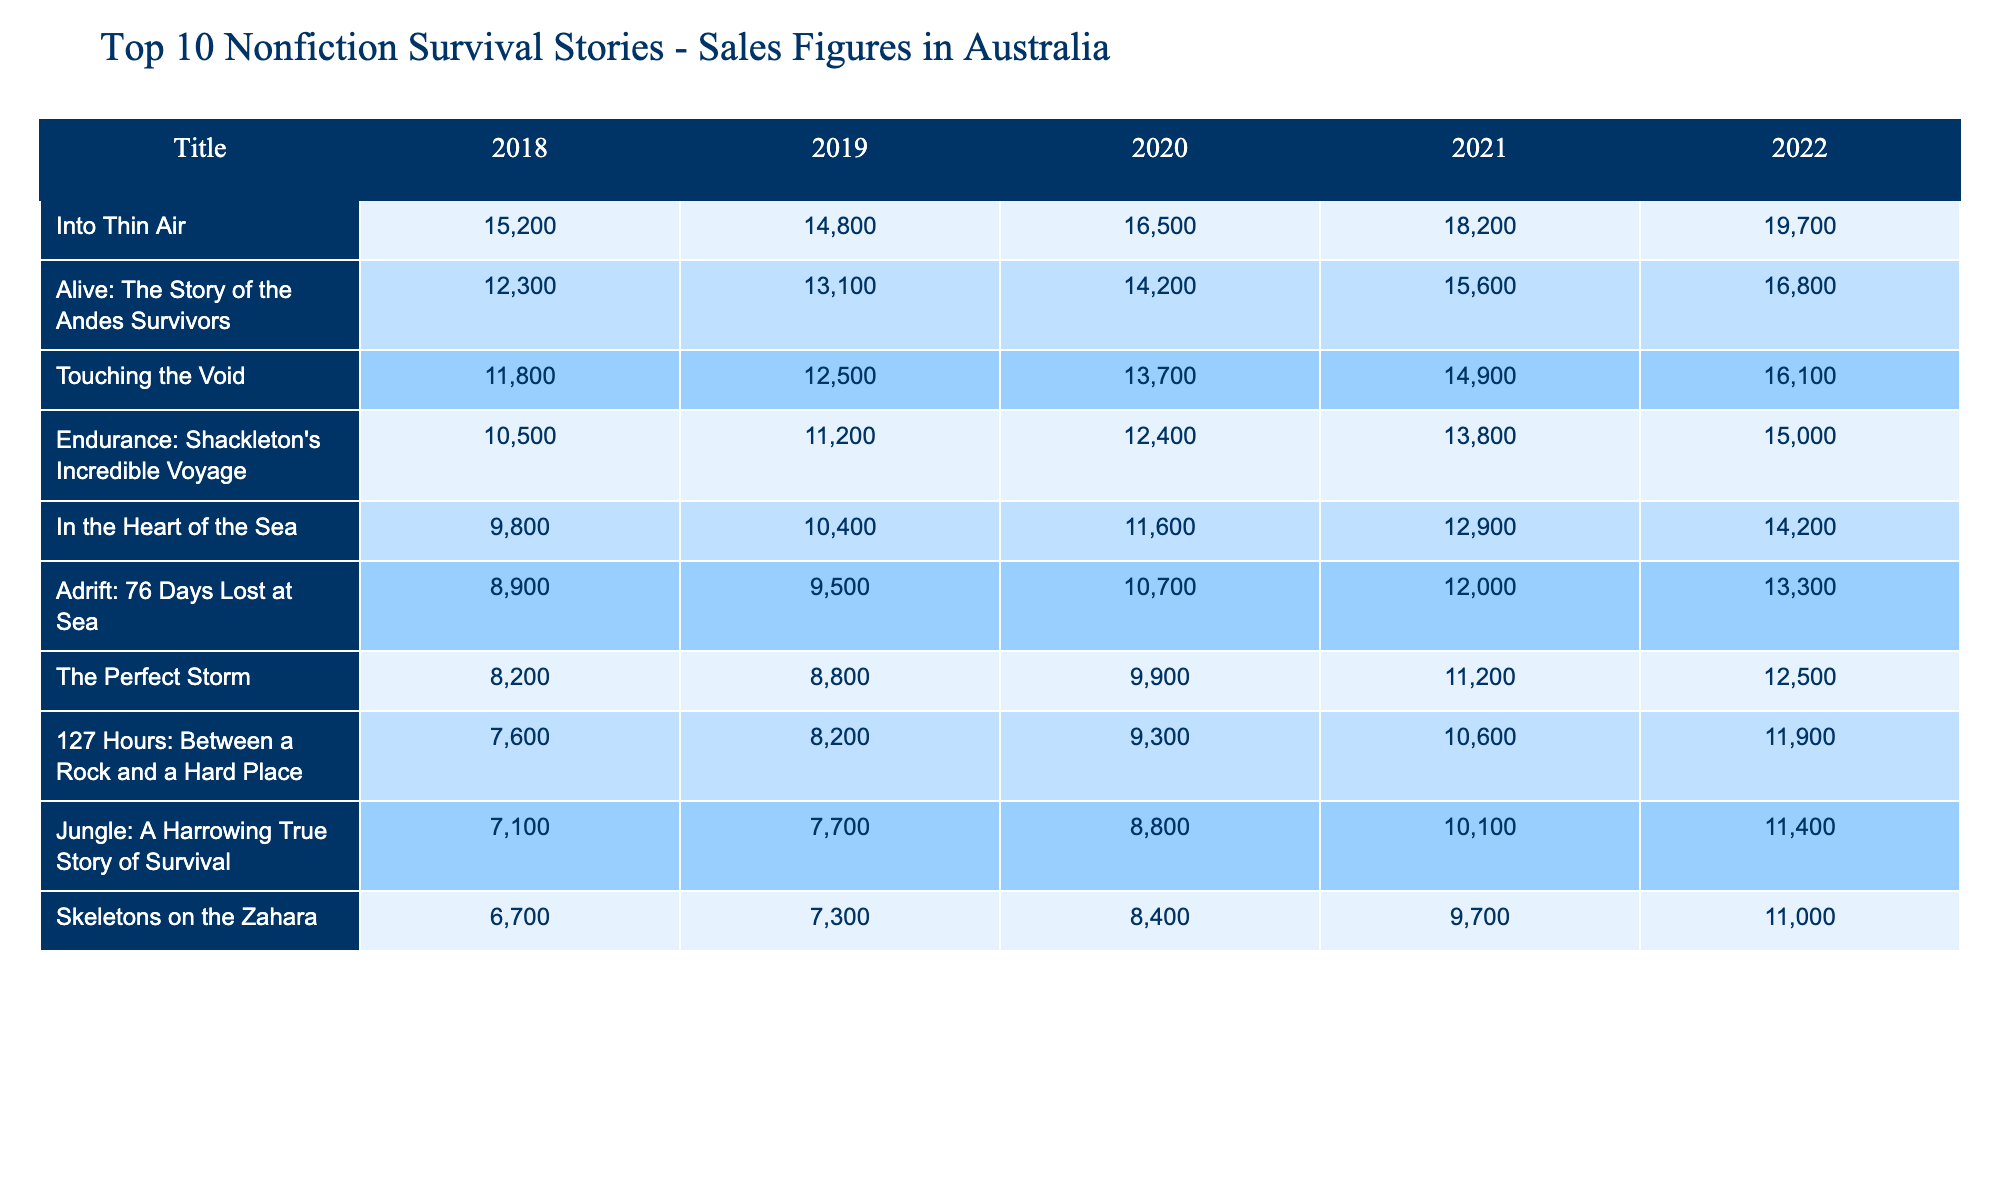What is the sales figure for "Touching the Void" in 2021? The table shows that "Touching the Void" sold 14,900 copies in 2021, as listed under the respective year column.
Answer: 14,900 Which book had the highest sales in 2022? By examining the last column for 2022, "Into Thin Air" is recorded with 19,700 sales, making it the highest selling book that year.
Answer: "Into Thin Air" What is the average sales figure for "Adrift: 76 Days Lost at Sea" over the five years? The sales figures for "Adrift: 76 Days Lost at Sea" over the five years are: 8,900, 9,500, 10,700, 12,000, and 13,300. The total is 8,900 + 9,500 + 10,700 + 12,000 + 13,300 = 54,400. To find the average, divide by 5: 54,400 / 5 = 10,880.
Answer: 10,880 Did the sales of "Endurance: Shackleton's Incredible Voyage" increase every year from 2018 to 2022? By checking each year's sales data for "Endurance: Shackleton's Incredible Voyage," we find it increased from 10,500 in 2018 to 15,000 in 2022. Since each value is greater than the previous one, the sales did increase every year.
Answer: Yes What book had the smallest sales in 2019, and what was the sales figure? In 2019, checking the sales figures reveals that "127 Hours: Between a Rock and a Hard Place" had the smallest sales figure of 8,200 compared to the others listed that year.
Answer: "127 Hours: Between a Rock and a Hard Place", 8,200 What was the difference in sales for "Alive: The Story of the Andes Survivors" between 2018 and 2022? The sales in 2018 were 12,300 and in 2022 they were 16,800. To find the difference, calculate 16,800 - 12,300 = 4,500.
Answer: 4,500 How many copies did the book "Skeletons on the Zahara" sell in total over the five years? The sales for "Skeletons on the Zahara" over the five years are: 6,700, 7,300, 8,400, 9,700, and 11,000. Summing these gives 6,700 + 7,300 + 8,400 + 9,700 + 11,000 = 43,100.
Answer: 43,100 Which book had the largest increase in sales from 2020 to 2021? Analyzing the increases from 2020 to 2021 for all books, "Into Thin Air" increased from 16,500 to 18,200 resulting in an increase of 1,700, which is the largest among them.
Answer: "Into Thin Air", 1,700 What was the total sales figure for the top three selling books in 2022? To find the total sales for the top three books in 2022, we sum the sales of "Into Thin Air" (19,700), "Alive: The Story of the Andes Survivors" (16,800), and "Touching the Void" (16,100). Thus, 19,700 + 16,800 + 16,100 = 52,600.
Answer: 52,600 Did "Jungle: A Harrowing True Story of Survival" ever surpass 10,000 sales in any year? Reviewing the sales figures, "Jungle" was below 10,000 in 2018 (7,100), 2019 (7,700), and 2020 (8,800) but reached 10,100 in 2021 and 11,400 in 2022. Therefore, it did surpass 10,000 in these later years.
Answer: Yes 